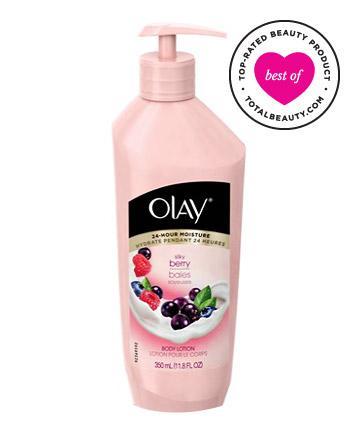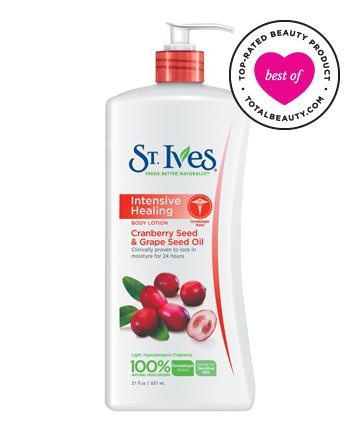The first image is the image on the left, the second image is the image on the right. Given the left and right images, does the statement "The images don't show the lotion being applied to anyone's skin." hold true? Answer yes or no. Yes. The first image is the image on the left, the second image is the image on the right. Analyze the images presented: Is the assertion "the left image is a single lotion bottle with a pump top" valid? Answer yes or no. Yes. 